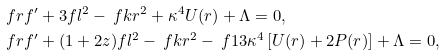<formula> <loc_0><loc_0><loc_500><loc_500>& \ f { r f ^ { \prime } + 3 f } { l ^ { 2 } } - \ f { k } { r ^ { 2 } } + \kappa ^ { 4 } U ( r ) + \Lambda = 0 , \\ & \ f { r f ^ { \prime } + ( 1 + 2 z ) f } { l ^ { 2 } } - \ f { k } { r ^ { 2 } } - \ f { 1 } { 3 } \kappa ^ { 4 } \left [ U ( r ) + 2 P ( r ) \right ] + \Lambda = 0 ,</formula> 